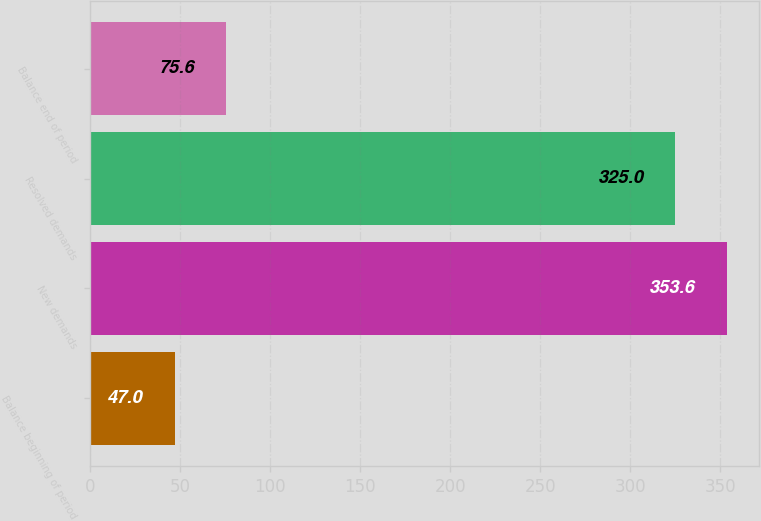<chart> <loc_0><loc_0><loc_500><loc_500><bar_chart><fcel>Balance beginning of period<fcel>New demands<fcel>Resolved demands<fcel>Balance end of period<nl><fcel>47<fcel>353.6<fcel>325<fcel>75.6<nl></chart> 